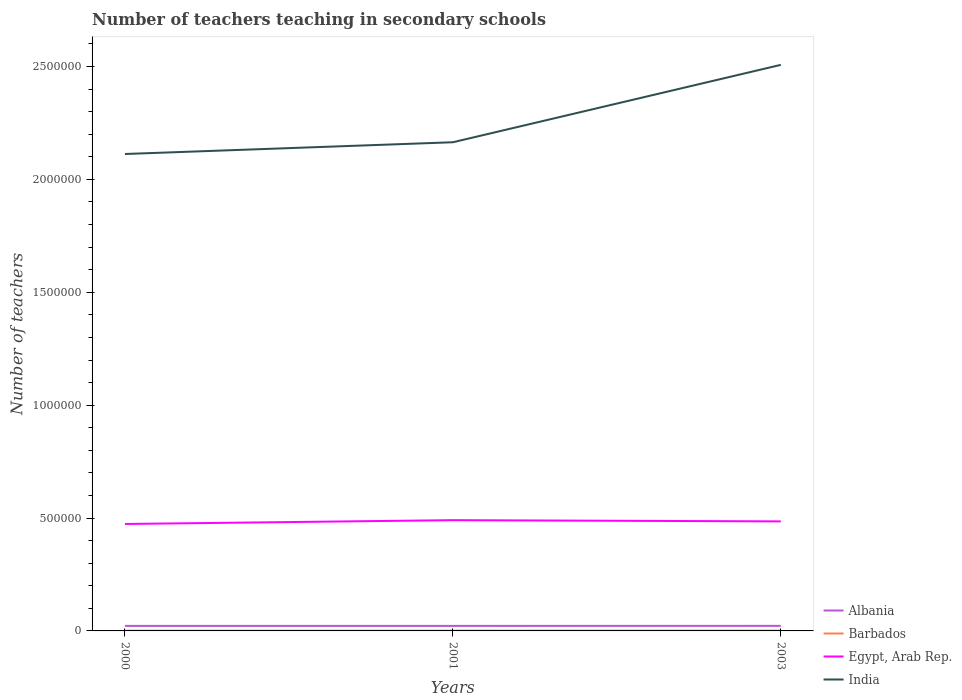How many different coloured lines are there?
Give a very brief answer. 4. Across all years, what is the maximum number of teachers teaching in secondary schools in India?
Provide a succinct answer. 2.11e+06. What is the total number of teachers teaching in secondary schools in India in the graph?
Your answer should be very brief. -3.43e+05. What is the difference between the highest and the second highest number of teachers teaching in secondary schools in Barbados?
Your answer should be compact. 171. Is the number of teachers teaching in secondary schools in Egypt, Arab Rep. strictly greater than the number of teachers teaching in secondary schools in Albania over the years?
Offer a very short reply. No. What is the difference between two consecutive major ticks on the Y-axis?
Provide a short and direct response. 5.00e+05. Where does the legend appear in the graph?
Make the answer very short. Bottom right. What is the title of the graph?
Provide a short and direct response. Number of teachers teaching in secondary schools. What is the label or title of the Y-axis?
Provide a short and direct response. Number of teachers. What is the Number of teachers in Albania in 2000?
Keep it short and to the point. 2.22e+04. What is the Number of teachers in Barbados in 2000?
Your answer should be compact. 1215. What is the Number of teachers in Egypt, Arab Rep. in 2000?
Your response must be concise. 4.74e+05. What is the Number of teachers of India in 2000?
Give a very brief answer. 2.11e+06. What is the Number of teachers of Albania in 2001?
Your response must be concise. 2.23e+04. What is the Number of teachers in Barbados in 2001?
Offer a very short reply. 1210. What is the Number of teachers in Egypt, Arab Rep. in 2001?
Your answer should be very brief. 4.91e+05. What is the Number of teachers in India in 2001?
Make the answer very short. 2.16e+06. What is the Number of teachers of Albania in 2003?
Provide a short and direct response. 2.24e+04. What is the Number of teachers in Barbados in 2003?
Keep it short and to the point. 1381. What is the Number of teachers in Egypt, Arab Rep. in 2003?
Your response must be concise. 4.85e+05. What is the Number of teachers in India in 2003?
Your answer should be very brief. 2.51e+06. Across all years, what is the maximum Number of teachers of Albania?
Give a very brief answer. 2.24e+04. Across all years, what is the maximum Number of teachers of Barbados?
Ensure brevity in your answer.  1381. Across all years, what is the maximum Number of teachers in Egypt, Arab Rep.?
Your response must be concise. 4.91e+05. Across all years, what is the maximum Number of teachers of India?
Provide a short and direct response. 2.51e+06. Across all years, what is the minimum Number of teachers in Albania?
Offer a very short reply. 2.22e+04. Across all years, what is the minimum Number of teachers in Barbados?
Offer a terse response. 1210. Across all years, what is the minimum Number of teachers in Egypt, Arab Rep.?
Make the answer very short. 4.74e+05. Across all years, what is the minimum Number of teachers of India?
Offer a terse response. 2.11e+06. What is the total Number of teachers of Albania in the graph?
Give a very brief answer. 6.70e+04. What is the total Number of teachers of Barbados in the graph?
Provide a succinct answer. 3806. What is the total Number of teachers of Egypt, Arab Rep. in the graph?
Make the answer very short. 1.45e+06. What is the total Number of teachers in India in the graph?
Offer a very short reply. 6.78e+06. What is the difference between the Number of teachers of Barbados in 2000 and that in 2001?
Your response must be concise. 5. What is the difference between the Number of teachers of Egypt, Arab Rep. in 2000 and that in 2001?
Your response must be concise. -1.69e+04. What is the difference between the Number of teachers of India in 2000 and that in 2001?
Offer a terse response. -5.20e+04. What is the difference between the Number of teachers of Albania in 2000 and that in 2003?
Ensure brevity in your answer.  -174. What is the difference between the Number of teachers in Barbados in 2000 and that in 2003?
Provide a short and direct response. -166. What is the difference between the Number of teachers in Egypt, Arab Rep. in 2000 and that in 2003?
Your answer should be very brief. -1.15e+04. What is the difference between the Number of teachers of India in 2000 and that in 2003?
Provide a short and direct response. -3.95e+05. What is the difference between the Number of teachers of Albania in 2001 and that in 2003?
Your answer should be compact. -144. What is the difference between the Number of teachers in Barbados in 2001 and that in 2003?
Make the answer very short. -171. What is the difference between the Number of teachers in Egypt, Arab Rep. in 2001 and that in 2003?
Make the answer very short. 5461. What is the difference between the Number of teachers of India in 2001 and that in 2003?
Keep it short and to the point. -3.43e+05. What is the difference between the Number of teachers in Albania in 2000 and the Number of teachers in Barbados in 2001?
Offer a very short reply. 2.10e+04. What is the difference between the Number of teachers of Albania in 2000 and the Number of teachers of Egypt, Arab Rep. in 2001?
Provide a succinct answer. -4.68e+05. What is the difference between the Number of teachers of Albania in 2000 and the Number of teachers of India in 2001?
Ensure brevity in your answer.  -2.14e+06. What is the difference between the Number of teachers in Barbados in 2000 and the Number of teachers in Egypt, Arab Rep. in 2001?
Ensure brevity in your answer.  -4.89e+05. What is the difference between the Number of teachers of Barbados in 2000 and the Number of teachers of India in 2001?
Give a very brief answer. -2.16e+06. What is the difference between the Number of teachers of Egypt, Arab Rep. in 2000 and the Number of teachers of India in 2001?
Provide a short and direct response. -1.69e+06. What is the difference between the Number of teachers of Albania in 2000 and the Number of teachers of Barbados in 2003?
Give a very brief answer. 2.09e+04. What is the difference between the Number of teachers of Albania in 2000 and the Number of teachers of Egypt, Arab Rep. in 2003?
Your response must be concise. -4.63e+05. What is the difference between the Number of teachers in Albania in 2000 and the Number of teachers in India in 2003?
Give a very brief answer. -2.49e+06. What is the difference between the Number of teachers in Barbados in 2000 and the Number of teachers in Egypt, Arab Rep. in 2003?
Offer a very short reply. -4.84e+05. What is the difference between the Number of teachers in Barbados in 2000 and the Number of teachers in India in 2003?
Provide a short and direct response. -2.51e+06. What is the difference between the Number of teachers in Egypt, Arab Rep. in 2000 and the Number of teachers in India in 2003?
Keep it short and to the point. -2.03e+06. What is the difference between the Number of teachers of Albania in 2001 and the Number of teachers of Barbados in 2003?
Provide a short and direct response. 2.09e+04. What is the difference between the Number of teachers of Albania in 2001 and the Number of teachers of Egypt, Arab Rep. in 2003?
Make the answer very short. -4.63e+05. What is the difference between the Number of teachers in Albania in 2001 and the Number of teachers in India in 2003?
Provide a succinct answer. -2.49e+06. What is the difference between the Number of teachers of Barbados in 2001 and the Number of teachers of Egypt, Arab Rep. in 2003?
Offer a very short reply. -4.84e+05. What is the difference between the Number of teachers in Barbados in 2001 and the Number of teachers in India in 2003?
Offer a terse response. -2.51e+06. What is the difference between the Number of teachers in Egypt, Arab Rep. in 2001 and the Number of teachers in India in 2003?
Make the answer very short. -2.02e+06. What is the average Number of teachers in Albania per year?
Make the answer very short. 2.23e+04. What is the average Number of teachers in Barbados per year?
Provide a short and direct response. 1268.67. What is the average Number of teachers in Egypt, Arab Rep. per year?
Ensure brevity in your answer.  4.83e+05. What is the average Number of teachers in India per year?
Provide a succinct answer. 2.26e+06. In the year 2000, what is the difference between the Number of teachers in Albania and Number of teachers in Barbados?
Your answer should be very brief. 2.10e+04. In the year 2000, what is the difference between the Number of teachers of Albania and Number of teachers of Egypt, Arab Rep.?
Your answer should be very brief. -4.51e+05. In the year 2000, what is the difference between the Number of teachers in Albania and Number of teachers in India?
Make the answer very short. -2.09e+06. In the year 2000, what is the difference between the Number of teachers of Barbados and Number of teachers of Egypt, Arab Rep.?
Make the answer very short. -4.72e+05. In the year 2000, what is the difference between the Number of teachers in Barbados and Number of teachers in India?
Ensure brevity in your answer.  -2.11e+06. In the year 2000, what is the difference between the Number of teachers of Egypt, Arab Rep. and Number of teachers of India?
Ensure brevity in your answer.  -1.64e+06. In the year 2001, what is the difference between the Number of teachers in Albania and Number of teachers in Barbados?
Offer a very short reply. 2.11e+04. In the year 2001, what is the difference between the Number of teachers in Albania and Number of teachers in Egypt, Arab Rep.?
Keep it short and to the point. -4.68e+05. In the year 2001, what is the difference between the Number of teachers in Albania and Number of teachers in India?
Your response must be concise. -2.14e+06. In the year 2001, what is the difference between the Number of teachers in Barbados and Number of teachers in Egypt, Arab Rep.?
Provide a succinct answer. -4.89e+05. In the year 2001, what is the difference between the Number of teachers of Barbados and Number of teachers of India?
Make the answer very short. -2.16e+06. In the year 2001, what is the difference between the Number of teachers of Egypt, Arab Rep. and Number of teachers of India?
Offer a terse response. -1.67e+06. In the year 2003, what is the difference between the Number of teachers of Albania and Number of teachers of Barbados?
Provide a succinct answer. 2.10e+04. In the year 2003, what is the difference between the Number of teachers in Albania and Number of teachers in Egypt, Arab Rep.?
Make the answer very short. -4.63e+05. In the year 2003, what is the difference between the Number of teachers in Albania and Number of teachers in India?
Your response must be concise. -2.48e+06. In the year 2003, what is the difference between the Number of teachers in Barbados and Number of teachers in Egypt, Arab Rep.?
Your answer should be compact. -4.84e+05. In the year 2003, what is the difference between the Number of teachers in Barbados and Number of teachers in India?
Your answer should be very brief. -2.51e+06. In the year 2003, what is the difference between the Number of teachers of Egypt, Arab Rep. and Number of teachers of India?
Offer a terse response. -2.02e+06. What is the ratio of the Number of teachers of Egypt, Arab Rep. in 2000 to that in 2001?
Make the answer very short. 0.97. What is the ratio of the Number of teachers in India in 2000 to that in 2001?
Provide a short and direct response. 0.98. What is the ratio of the Number of teachers in Barbados in 2000 to that in 2003?
Offer a terse response. 0.88. What is the ratio of the Number of teachers of Egypt, Arab Rep. in 2000 to that in 2003?
Offer a very short reply. 0.98. What is the ratio of the Number of teachers of India in 2000 to that in 2003?
Offer a terse response. 0.84. What is the ratio of the Number of teachers in Barbados in 2001 to that in 2003?
Offer a terse response. 0.88. What is the ratio of the Number of teachers of Egypt, Arab Rep. in 2001 to that in 2003?
Your response must be concise. 1.01. What is the ratio of the Number of teachers of India in 2001 to that in 2003?
Offer a terse response. 0.86. What is the difference between the highest and the second highest Number of teachers of Albania?
Make the answer very short. 144. What is the difference between the highest and the second highest Number of teachers in Barbados?
Your answer should be very brief. 166. What is the difference between the highest and the second highest Number of teachers of Egypt, Arab Rep.?
Make the answer very short. 5461. What is the difference between the highest and the second highest Number of teachers in India?
Provide a succinct answer. 3.43e+05. What is the difference between the highest and the lowest Number of teachers of Albania?
Make the answer very short. 174. What is the difference between the highest and the lowest Number of teachers of Barbados?
Your response must be concise. 171. What is the difference between the highest and the lowest Number of teachers in Egypt, Arab Rep.?
Keep it short and to the point. 1.69e+04. What is the difference between the highest and the lowest Number of teachers of India?
Provide a succinct answer. 3.95e+05. 